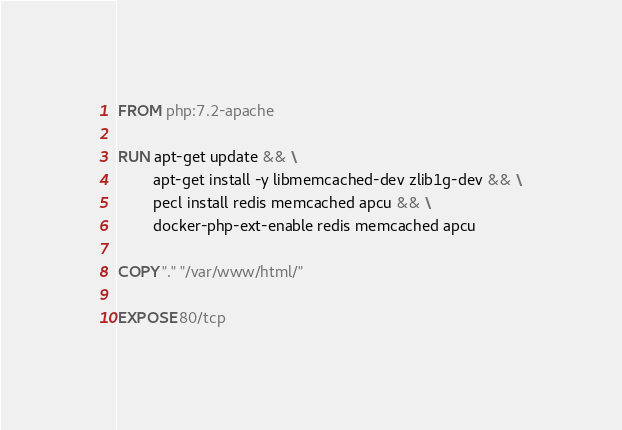<code> <loc_0><loc_0><loc_500><loc_500><_Dockerfile_>FROM php:7.2-apache

RUN apt-get update && \
        apt-get install -y libmemcached-dev zlib1g-dev && \
        pecl install redis memcached apcu && \
        docker-php-ext-enable redis memcached apcu

COPY "." "/var/www/html/"

EXPOSE 80/tcp
</code> 